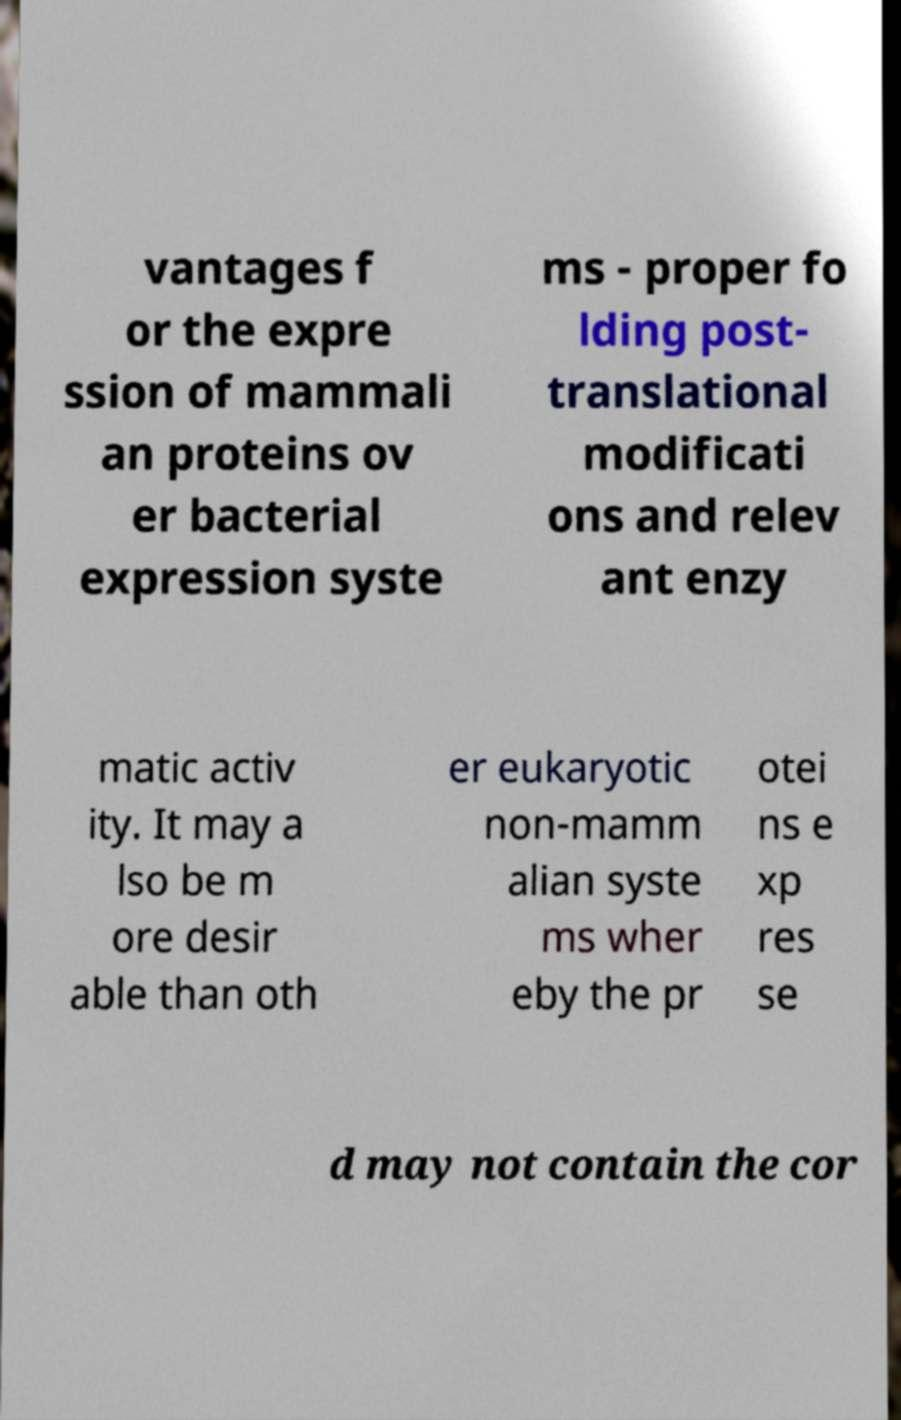Please identify and transcribe the text found in this image. vantages f or the expre ssion of mammali an proteins ov er bacterial expression syste ms - proper fo lding post- translational modificati ons and relev ant enzy matic activ ity. It may a lso be m ore desir able than oth er eukaryotic non-mamm alian syste ms wher eby the pr otei ns e xp res se d may not contain the cor 